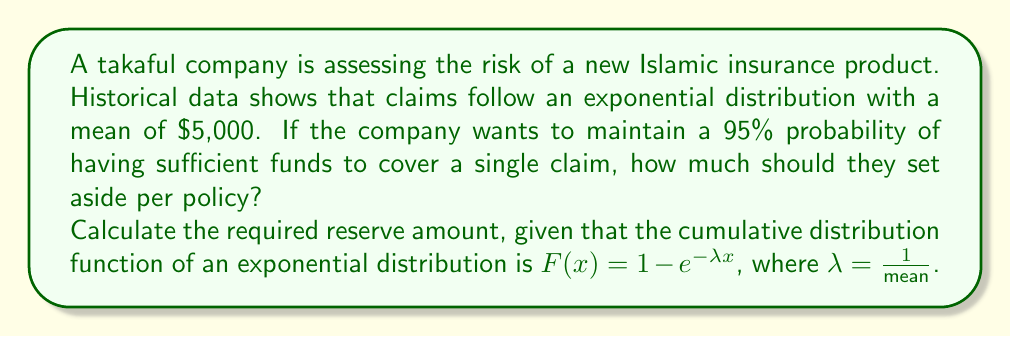Can you answer this question? To solve this problem, we'll follow these steps:

1) First, we need to identify the parameters:
   - Mean of the exponential distribution: $\mu = 5000$
   - Desired probability: $P = 0.95$

2) For an exponential distribution, $\lambda = \frac{1}{\mu} = \frac{1}{5000}$

3) We want to find $x$ such that $P(X \leq x) = 0.95$

4) Using the cumulative distribution function:

   $F(x) = 1 - e^{-\lambda x} = 0.95$

5) Solving for $x$:

   $1 - e^{-\lambda x} = 0.95$
   $e^{-\lambda x} = 0.05$
   $-\lambda x = \ln(0.05)$
   $x = -\frac{\ln(0.05)}{\lambda}$

6) Substituting $\lambda = \frac{1}{5000}$:

   $x = -5000 \ln(0.05)$

7) Calculating the result:

   $x \approx 14978.66$

Therefore, the takaful company should set aside approximately $14,978.66 per policy to have a 95% probability of covering a single claim.
Answer: $14,978.66 